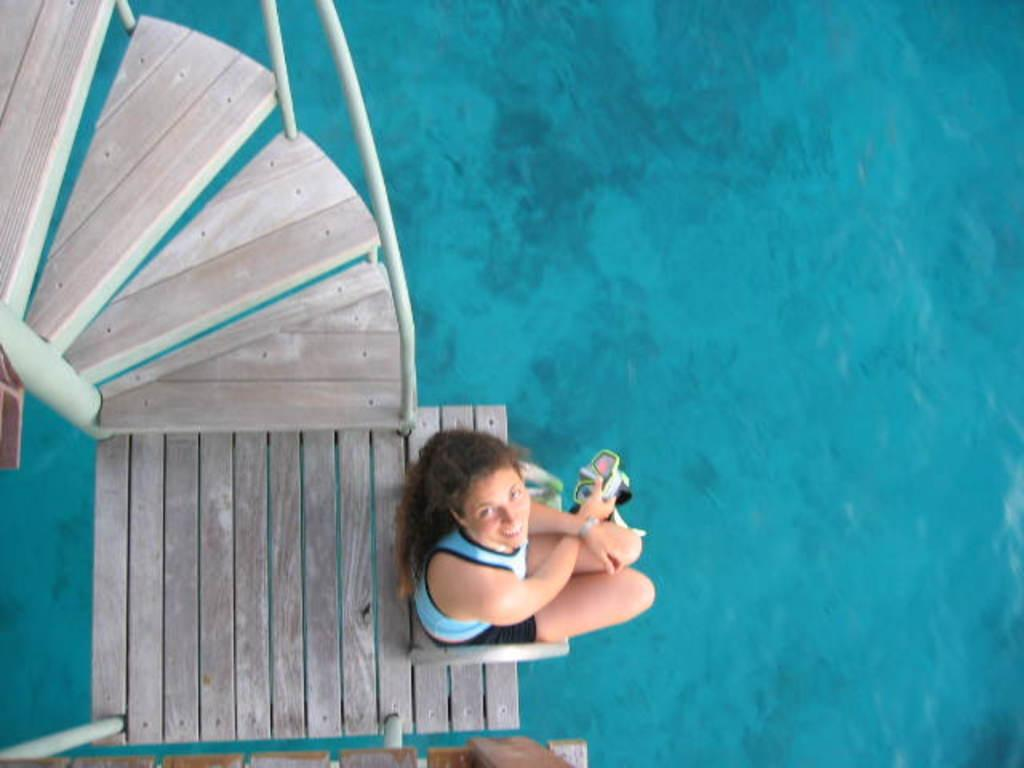Who is present in the image? There is a woman in the image. What is the woman holding in her hand? The woman is holding an object in her hand. What architectural feature can be seen in the image? There is a staircase in the image. What natural element is visible in the image? There is water visible in the image. What type of beef can be seen on the woman's suit in the image? There is no beef or suit present in the image. Can you tell me how many zebras are visible in the water? There are no zebras visible in the image; only a woman and a staircase are present. 